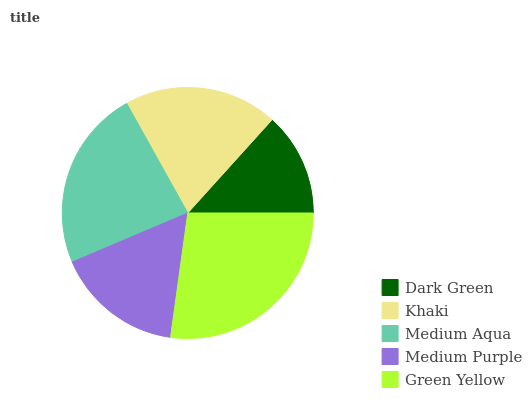Is Dark Green the minimum?
Answer yes or no. Yes. Is Green Yellow the maximum?
Answer yes or no. Yes. Is Khaki the minimum?
Answer yes or no. No. Is Khaki the maximum?
Answer yes or no. No. Is Khaki greater than Dark Green?
Answer yes or no. Yes. Is Dark Green less than Khaki?
Answer yes or no. Yes. Is Dark Green greater than Khaki?
Answer yes or no. No. Is Khaki less than Dark Green?
Answer yes or no. No. Is Khaki the high median?
Answer yes or no. Yes. Is Khaki the low median?
Answer yes or no. Yes. Is Medium Purple the high median?
Answer yes or no. No. Is Medium Aqua the low median?
Answer yes or no. No. 